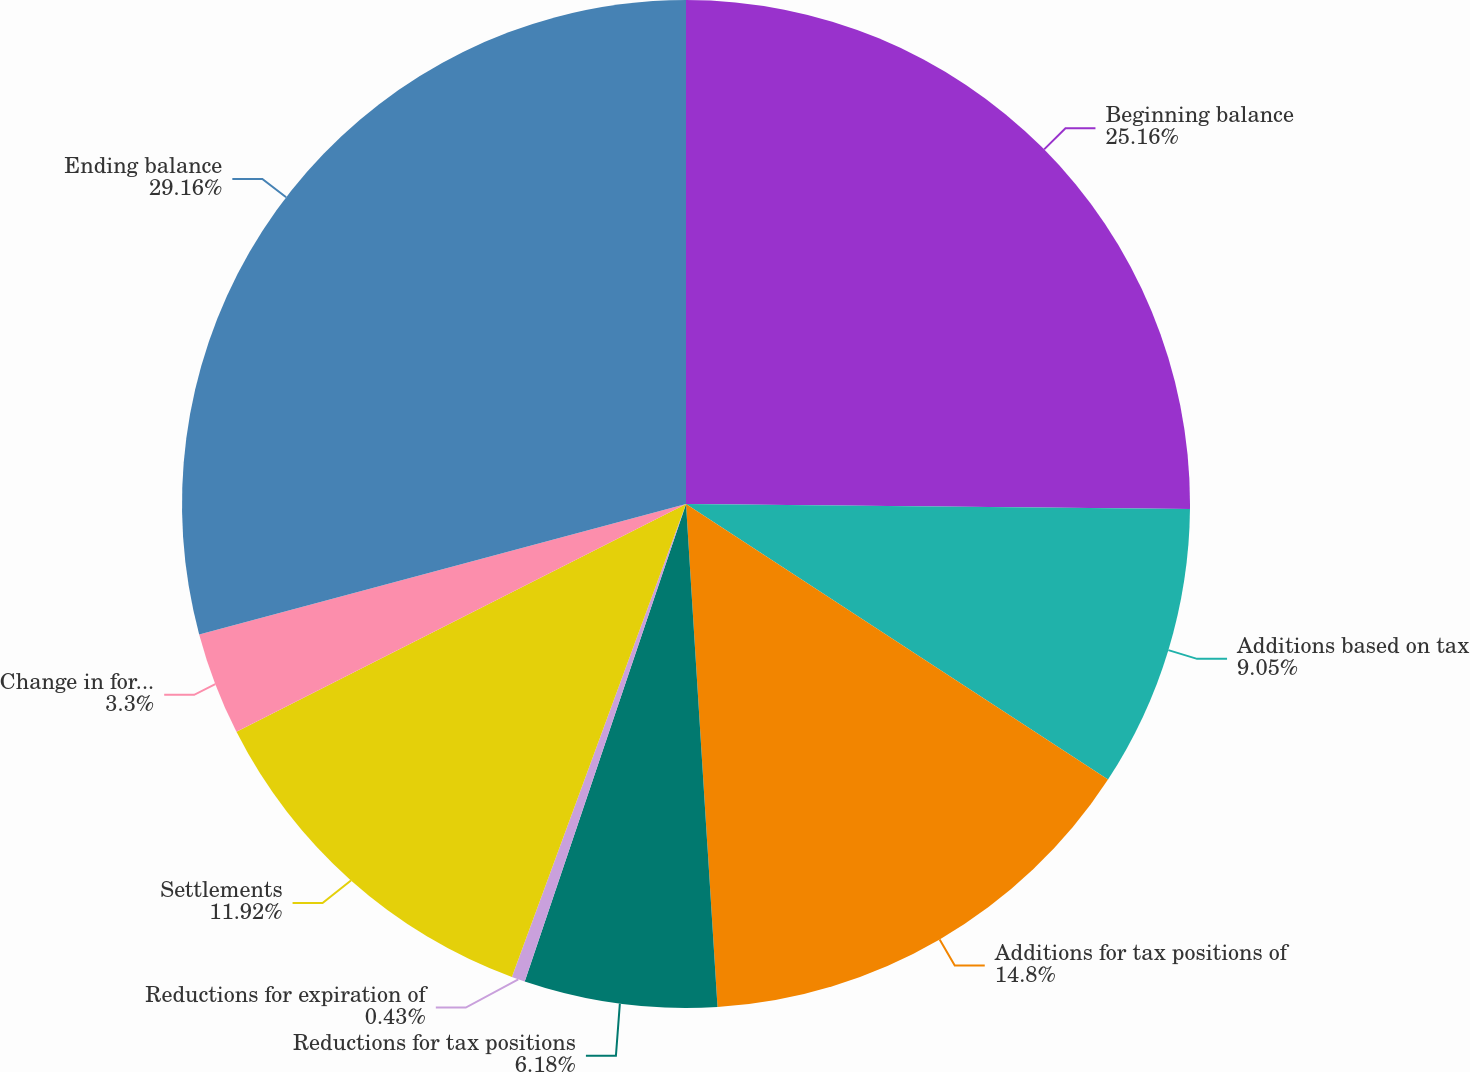Convert chart to OTSL. <chart><loc_0><loc_0><loc_500><loc_500><pie_chart><fcel>Beginning balance<fcel>Additions based on tax<fcel>Additions for tax positions of<fcel>Reductions for tax positions<fcel>Reductions for expiration of<fcel>Settlements<fcel>Change in foreign currency<fcel>Ending balance<nl><fcel>25.16%<fcel>9.05%<fcel>14.8%<fcel>6.18%<fcel>0.43%<fcel>11.92%<fcel>3.3%<fcel>29.17%<nl></chart> 